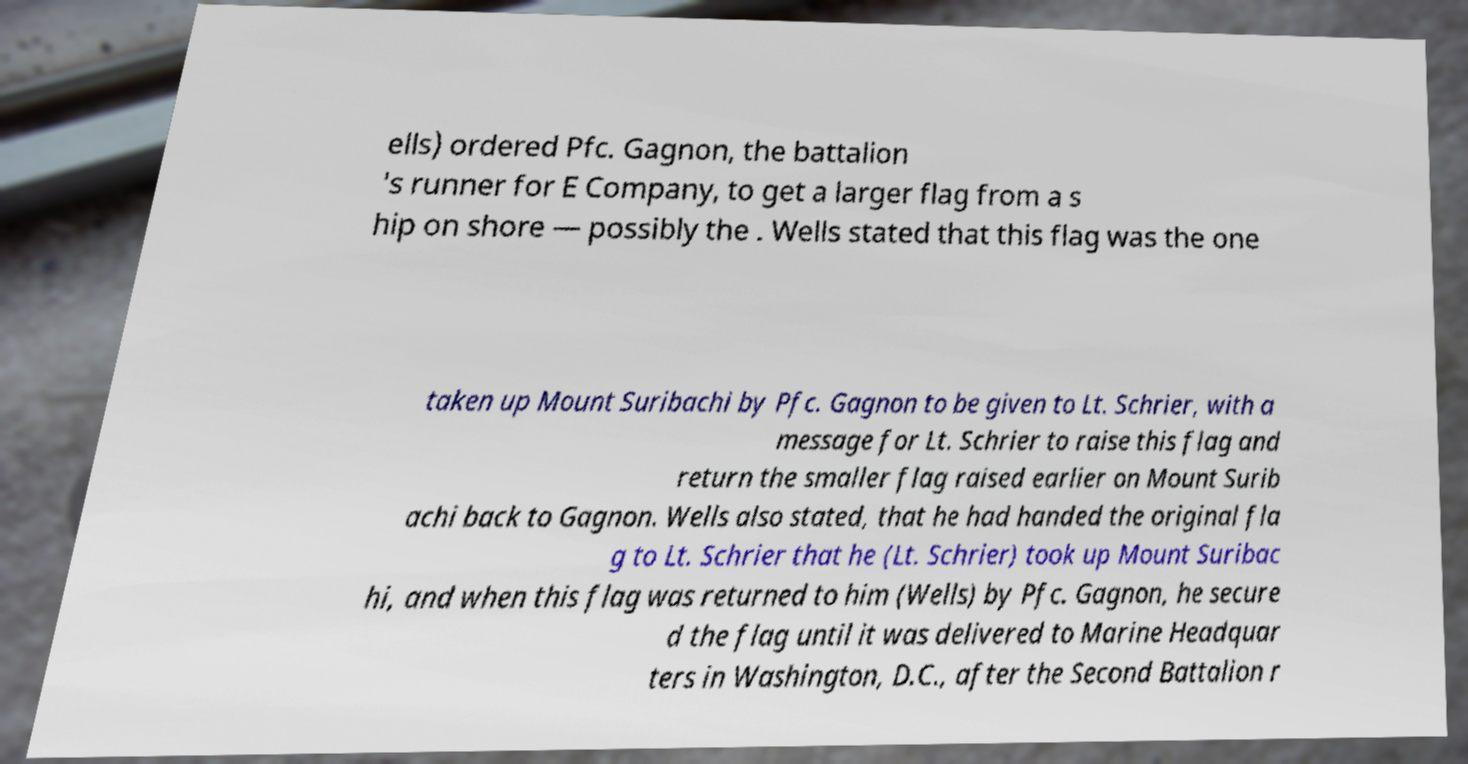Please read and relay the text visible in this image. What does it say? ells) ordered Pfc. Gagnon, the battalion 's runner for E Company, to get a larger flag from a s hip on shore — possibly the . Wells stated that this flag was the one taken up Mount Suribachi by Pfc. Gagnon to be given to Lt. Schrier, with a message for Lt. Schrier to raise this flag and return the smaller flag raised earlier on Mount Surib achi back to Gagnon. Wells also stated, that he had handed the original fla g to Lt. Schrier that he (Lt. Schrier) took up Mount Suribac hi, and when this flag was returned to him (Wells) by Pfc. Gagnon, he secure d the flag until it was delivered to Marine Headquar ters in Washington, D.C., after the Second Battalion r 